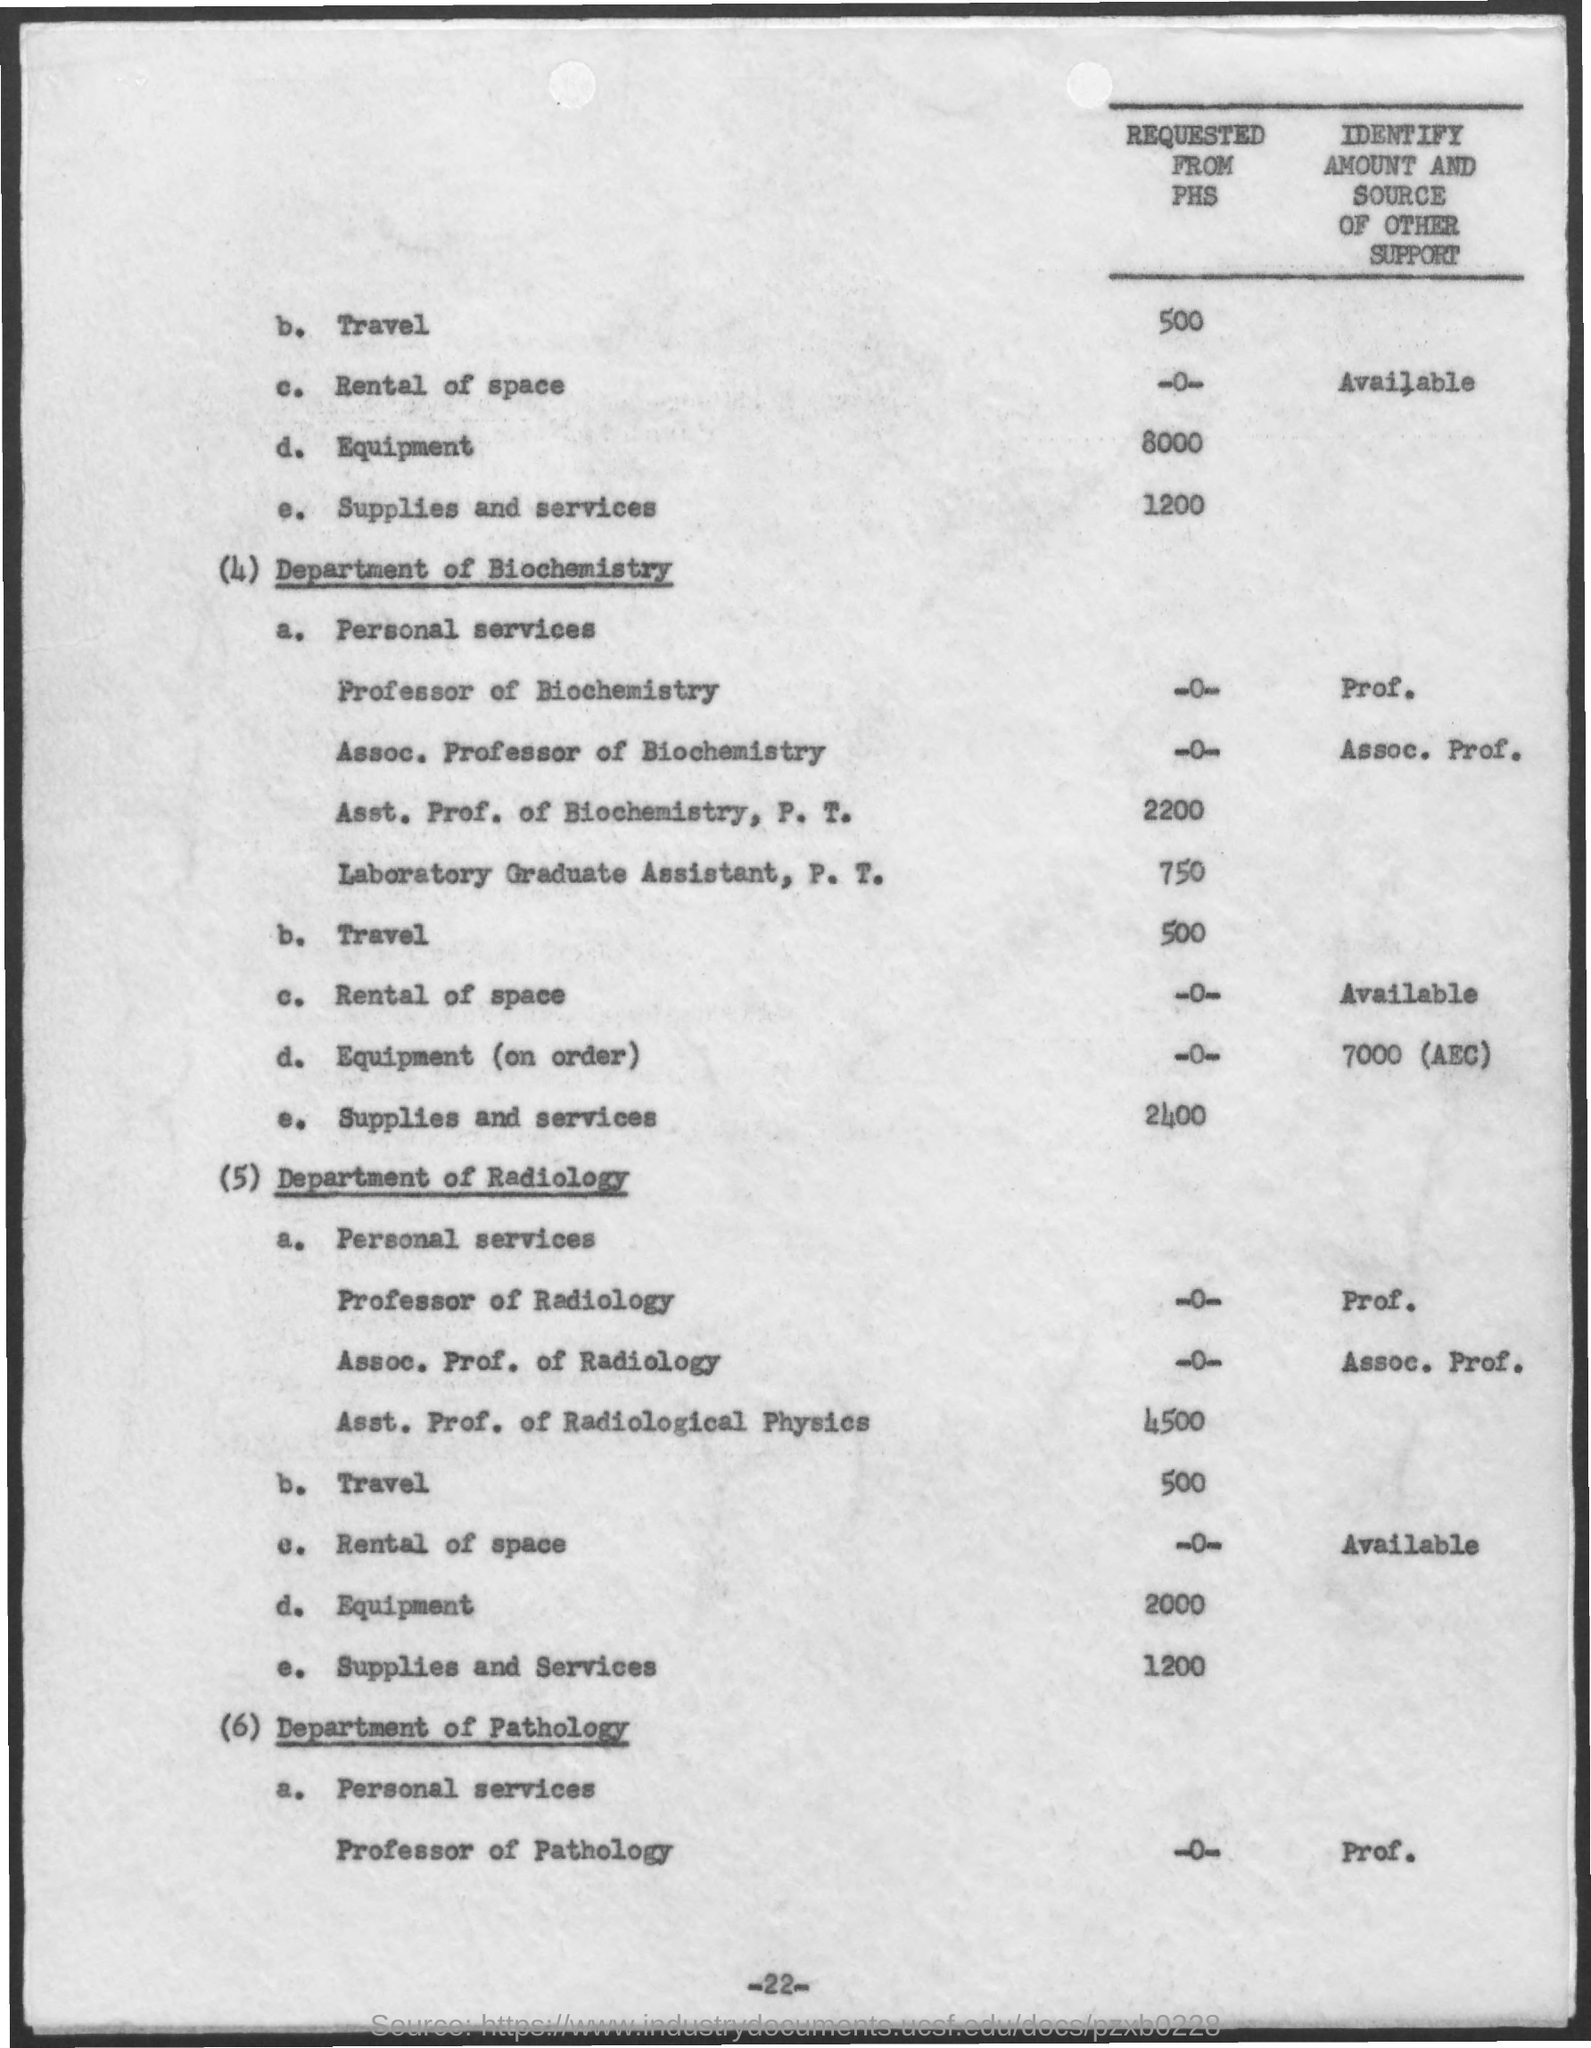What is the amount for travel mentioned in the department of radiology ?
Your answer should be very brief. 500. What is the amount mentioned for supplies and services in department of biochemistry ?
Keep it short and to the point. 2400. What is the amount mentioned for supplies and services in the department of radiology ?
Keep it short and to the point. 1200. 